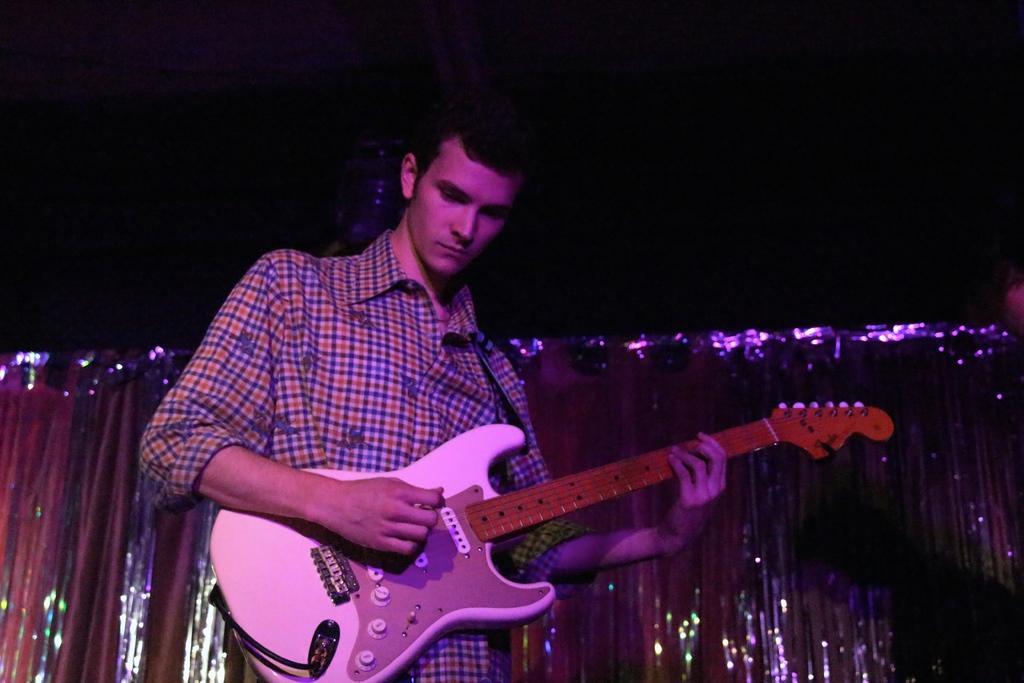How would you summarize this image in a sentence or two? This image consists of a man playing a guitar. At the top, the sky is dark. 